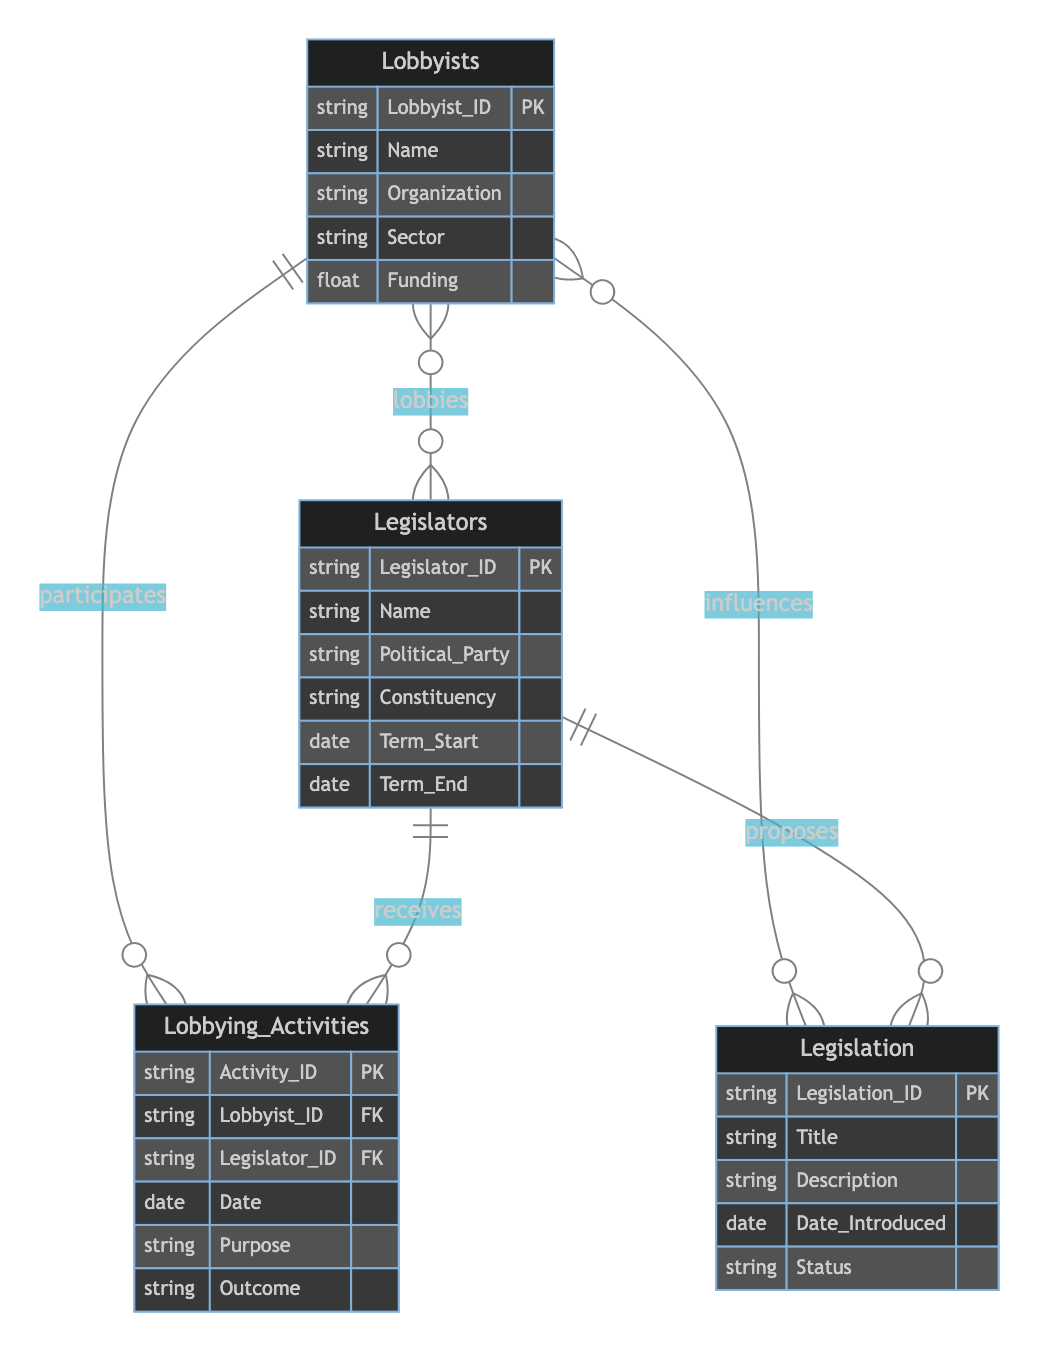What are the entities present in the diagram? The diagram features four entities: Lobbyists, Legislators, Legislation, and Lobbying Activities.
Answer: Lobbyists, Legislators, Legislation, Lobbying Activities How many attributes does the entity 'Lobbyists' have? The 'Lobbyists' entity consists of five attributes: Lobbyist_ID, Name, Organization, Sector, and Funding.
Answer: 5 Which entity proposes legislation? The 'Legislators' entity is responsible for proposing legislation as indicated by the relationship labeled 'Proposes'.
Answer: Legislators What is the relationship type between Lobbyists and Legislators? The relationship between Lobbyists and Legislators is Many-to-Many, denoted by the 'Lobbies' relationship.
Answer: Many-to-Many How many entities are directly influenced by Lobbyists? The diagram indicates that Lobbyists influence multiple entities, specifically Legislation, through a Many-to-Many relationship.
Answer: Legislation What is the total number of relationships in the diagram? There are three defined relationships present in the diagram: Influences, Proposes, and Lobbies.
Answer: 3 What does the 'Lobbying_Activities' table represent? The 'Lobbying_Activities' table captures the participation of Lobbyists and Legislators in lobbying efforts, detailing specific activities.
Answer: Participation How many types of relationships involve the 'Legislation' entity? The 'Legislation' entity is involved in two types of relationships: 'Influences' and 'Proposes'.
Answer: 2 What type of relationship is 'Influences'? The 'Influences' relationship is categorized as Many-to-Many between Lobbyists and Legislation.
Answer: Many-to-Many 